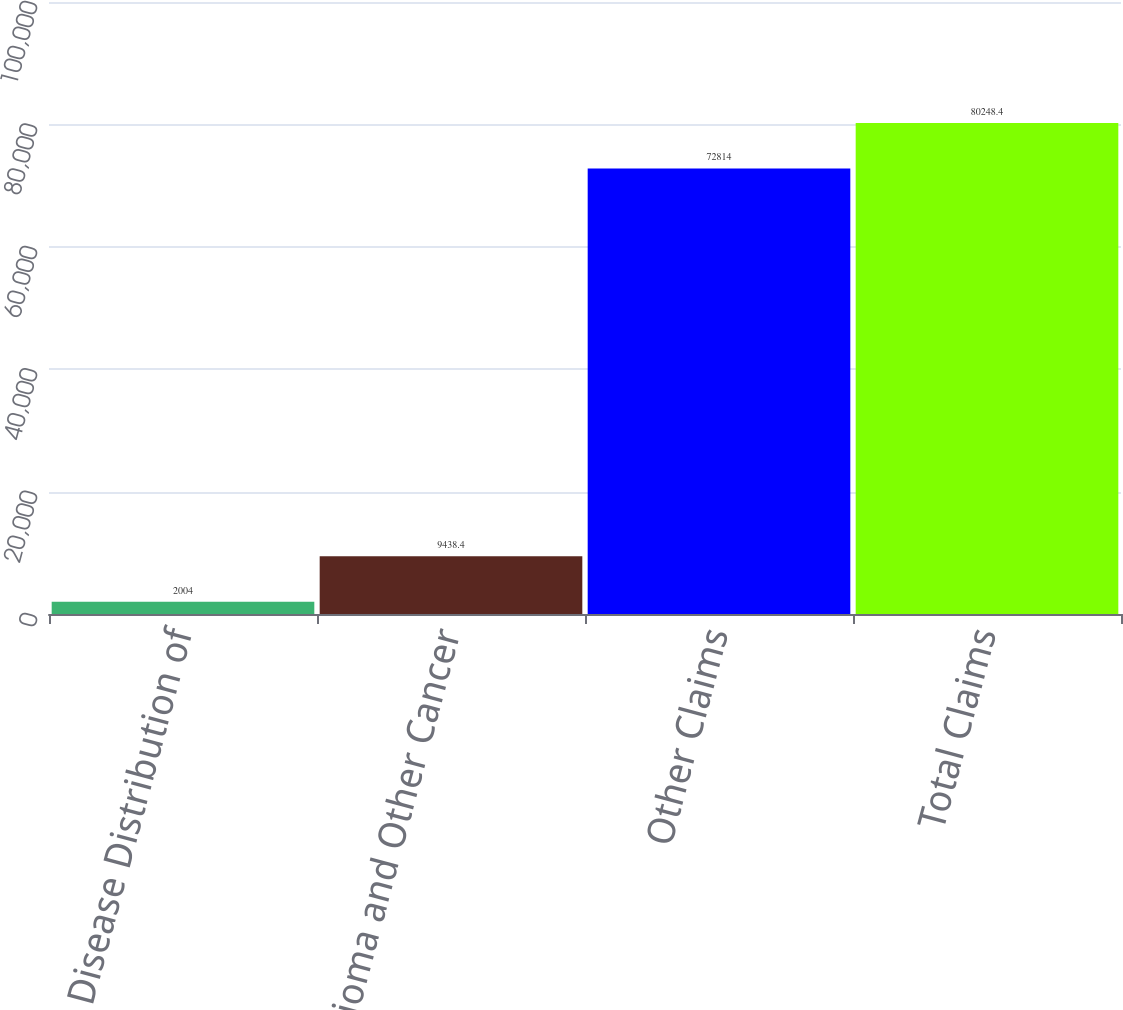Convert chart. <chart><loc_0><loc_0><loc_500><loc_500><bar_chart><fcel>Disease Distribution of<fcel>Mesothelioma and Other Cancer<fcel>Other Claims<fcel>Total Claims<nl><fcel>2004<fcel>9438.4<fcel>72814<fcel>80248.4<nl></chart> 